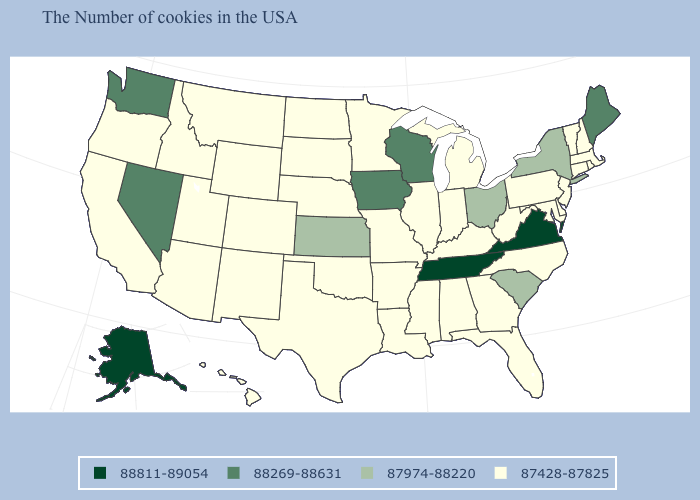What is the value of Alaska?
Write a very short answer. 88811-89054. How many symbols are there in the legend?
Concise answer only. 4. What is the value of Delaware?
Short answer required. 87428-87825. Does Alaska have the highest value in the West?
Answer briefly. Yes. Does Oregon have the same value as Ohio?
Give a very brief answer. No. How many symbols are there in the legend?
Concise answer only. 4. Name the states that have a value in the range 88269-88631?
Give a very brief answer. Maine, Wisconsin, Iowa, Nevada, Washington. What is the value of Hawaii?
Quick response, please. 87428-87825. Does the first symbol in the legend represent the smallest category?
Be succinct. No. What is the value of California?
Write a very short answer. 87428-87825. What is the value of Florida?
Quick response, please. 87428-87825. Which states have the lowest value in the West?
Short answer required. Wyoming, Colorado, New Mexico, Utah, Montana, Arizona, Idaho, California, Oregon, Hawaii. Does the map have missing data?
Be succinct. No. Name the states that have a value in the range 88811-89054?
Concise answer only. Virginia, Tennessee, Alaska. 